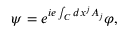Convert formula to latex. <formula><loc_0><loc_0><loc_500><loc_500>\psi = e ^ { i e \int _ { C } d x ^ { j } A _ { j } } \varphi ,</formula> 